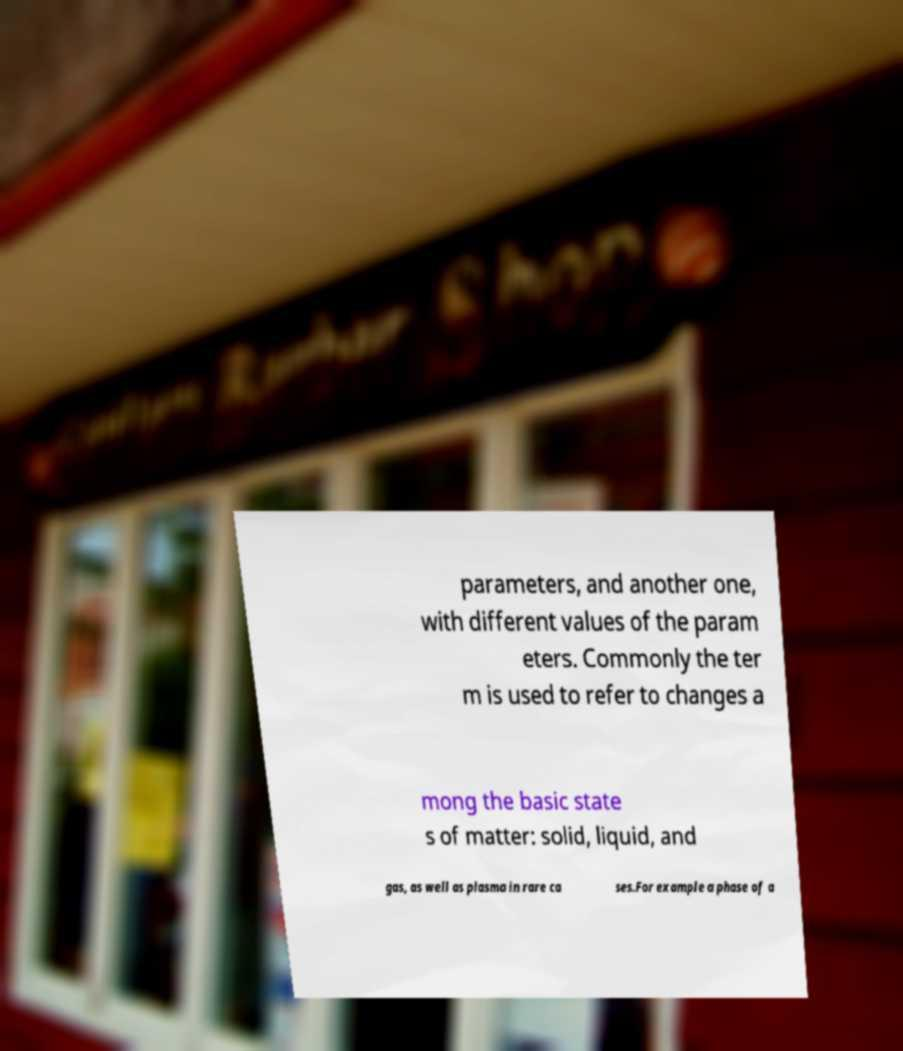What messages or text are displayed in this image? I need them in a readable, typed format. parameters, and another one, with different values of the param eters. Commonly the ter m is used to refer to changes a mong the basic state s of matter: solid, liquid, and gas, as well as plasma in rare ca ses.For example a phase of a 